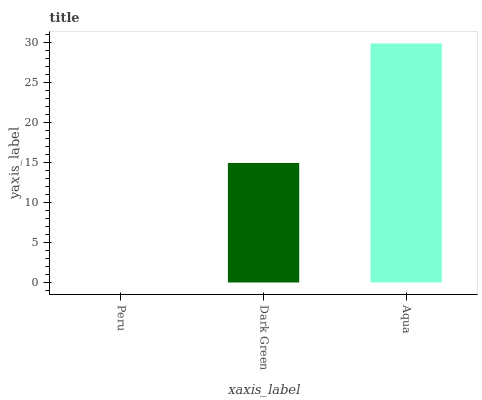Is Peru the minimum?
Answer yes or no. Yes. Is Aqua the maximum?
Answer yes or no. Yes. Is Dark Green the minimum?
Answer yes or no. No. Is Dark Green the maximum?
Answer yes or no. No. Is Dark Green greater than Peru?
Answer yes or no. Yes. Is Peru less than Dark Green?
Answer yes or no. Yes. Is Peru greater than Dark Green?
Answer yes or no. No. Is Dark Green less than Peru?
Answer yes or no. No. Is Dark Green the high median?
Answer yes or no. Yes. Is Dark Green the low median?
Answer yes or no. Yes. Is Peru the high median?
Answer yes or no. No. Is Aqua the low median?
Answer yes or no. No. 